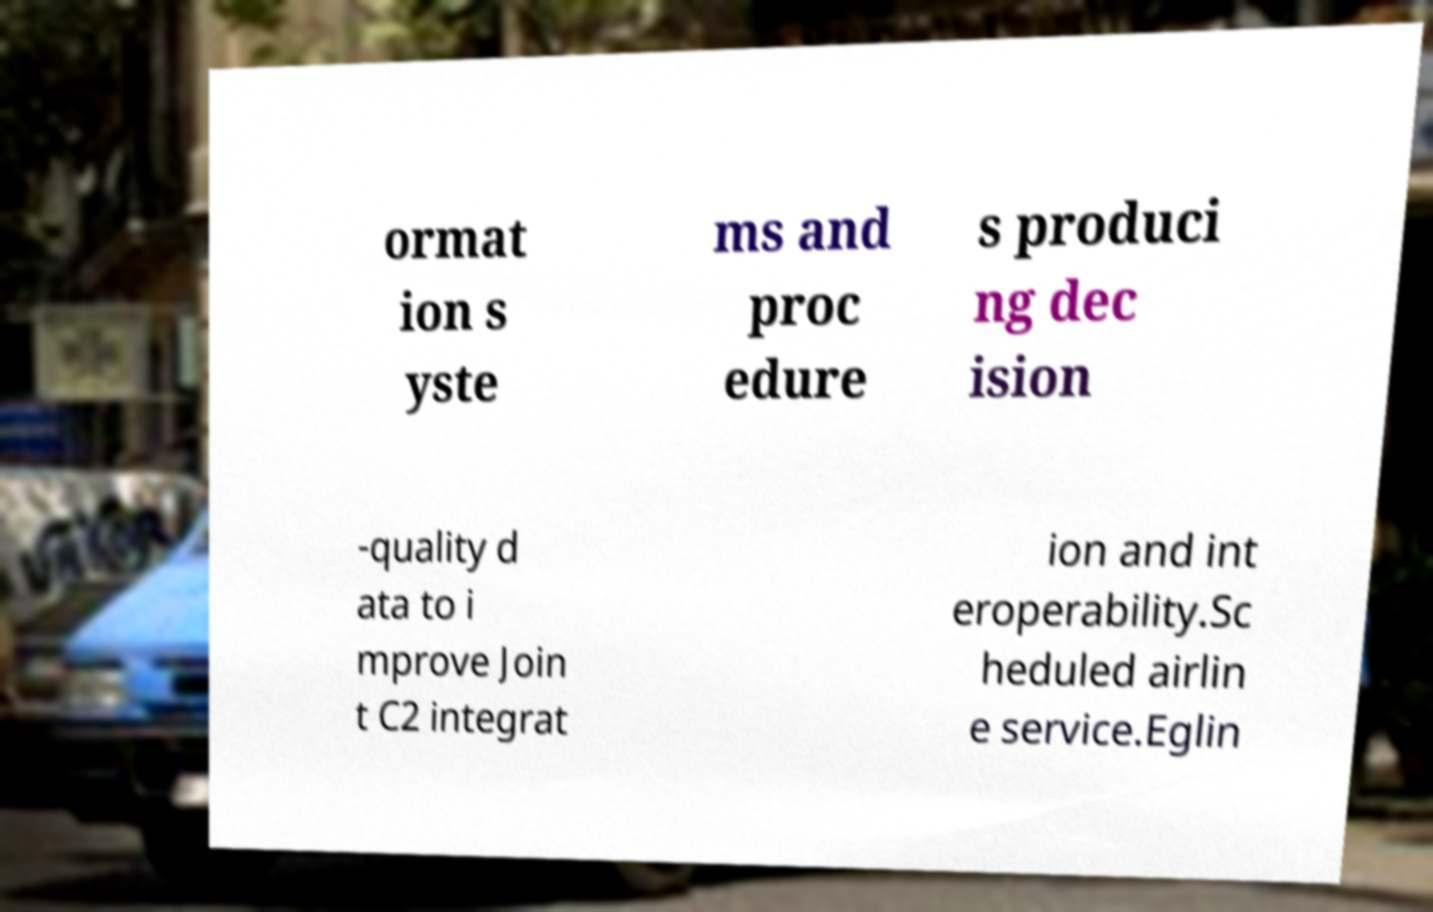There's text embedded in this image that I need extracted. Can you transcribe it verbatim? ormat ion s yste ms and proc edure s produci ng dec ision -quality d ata to i mprove Join t C2 integrat ion and int eroperability.Sc heduled airlin e service.Eglin 